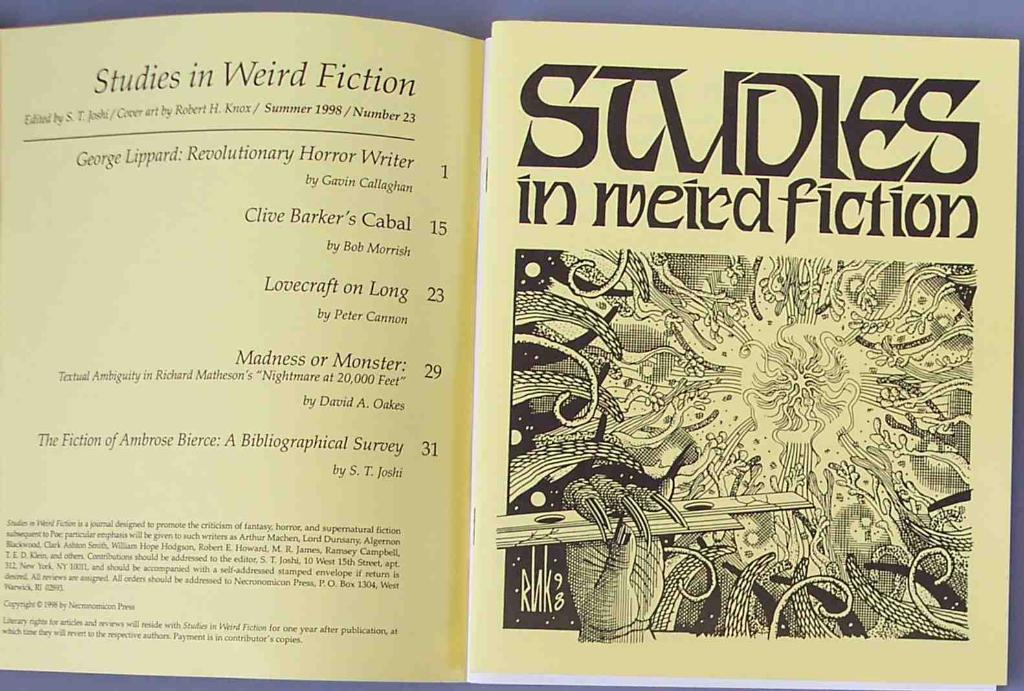<image>
Give a short and clear explanation of the subsequent image. A book or pamphlet open up to the contents saying Studies in weird fiction. 